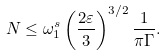Convert formula to latex. <formula><loc_0><loc_0><loc_500><loc_500>N \leq \omega _ { 1 } ^ { s } \left ( \frac { 2 \varepsilon } { 3 } \right ) ^ { 3 / 2 } \frac { 1 } { \pi \Gamma } .</formula> 